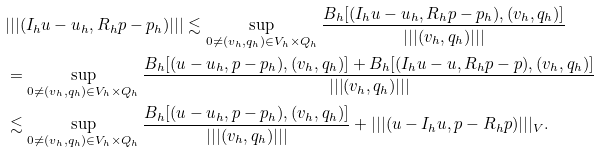Convert formula to latex. <formula><loc_0><loc_0><loc_500><loc_500>& | | | ( I _ { h } u - u _ { h } , R _ { h } p - p _ { h } ) | | | \lesssim \sup _ { 0 \neq ( v _ { h } , q _ { h } ) \in V _ { h } \times Q _ { h } } \frac { B _ { h } [ ( I _ { h } u - u _ { h } , R _ { h } p - p _ { h } ) , ( v _ { h } , q _ { h } ) ] } { | | | ( v _ { h } , q _ { h } ) | | | } \\ & = \sup _ { 0 \neq ( v _ { h } , q _ { h } ) \in V _ { h } \times Q _ { h } } \frac { B _ { h } [ ( u - u _ { h } , p - p _ { h } ) , ( v _ { h } , q _ { h } ) ] + B _ { h } [ ( I _ { h } u - u , R _ { h } p - p ) , ( v _ { h } , q _ { h } ) ] } { | | | ( v _ { h } , q _ { h } ) | | | } \\ & \lesssim \sup _ { 0 \neq ( v _ { h } , q _ { h } ) \in V _ { h } \times Q _ { h } } \frac { B _ { h } [ ( u - u _ { h } , p - p _ { h } ) , ( v _ { h } , q _ { h } ) ] } { | | | ( v _ { h } , q _ { h } ) | | | } + | | | ( u - I _ { h } u , p - R _ { h } p ) | | | _ { V } .</formula> 